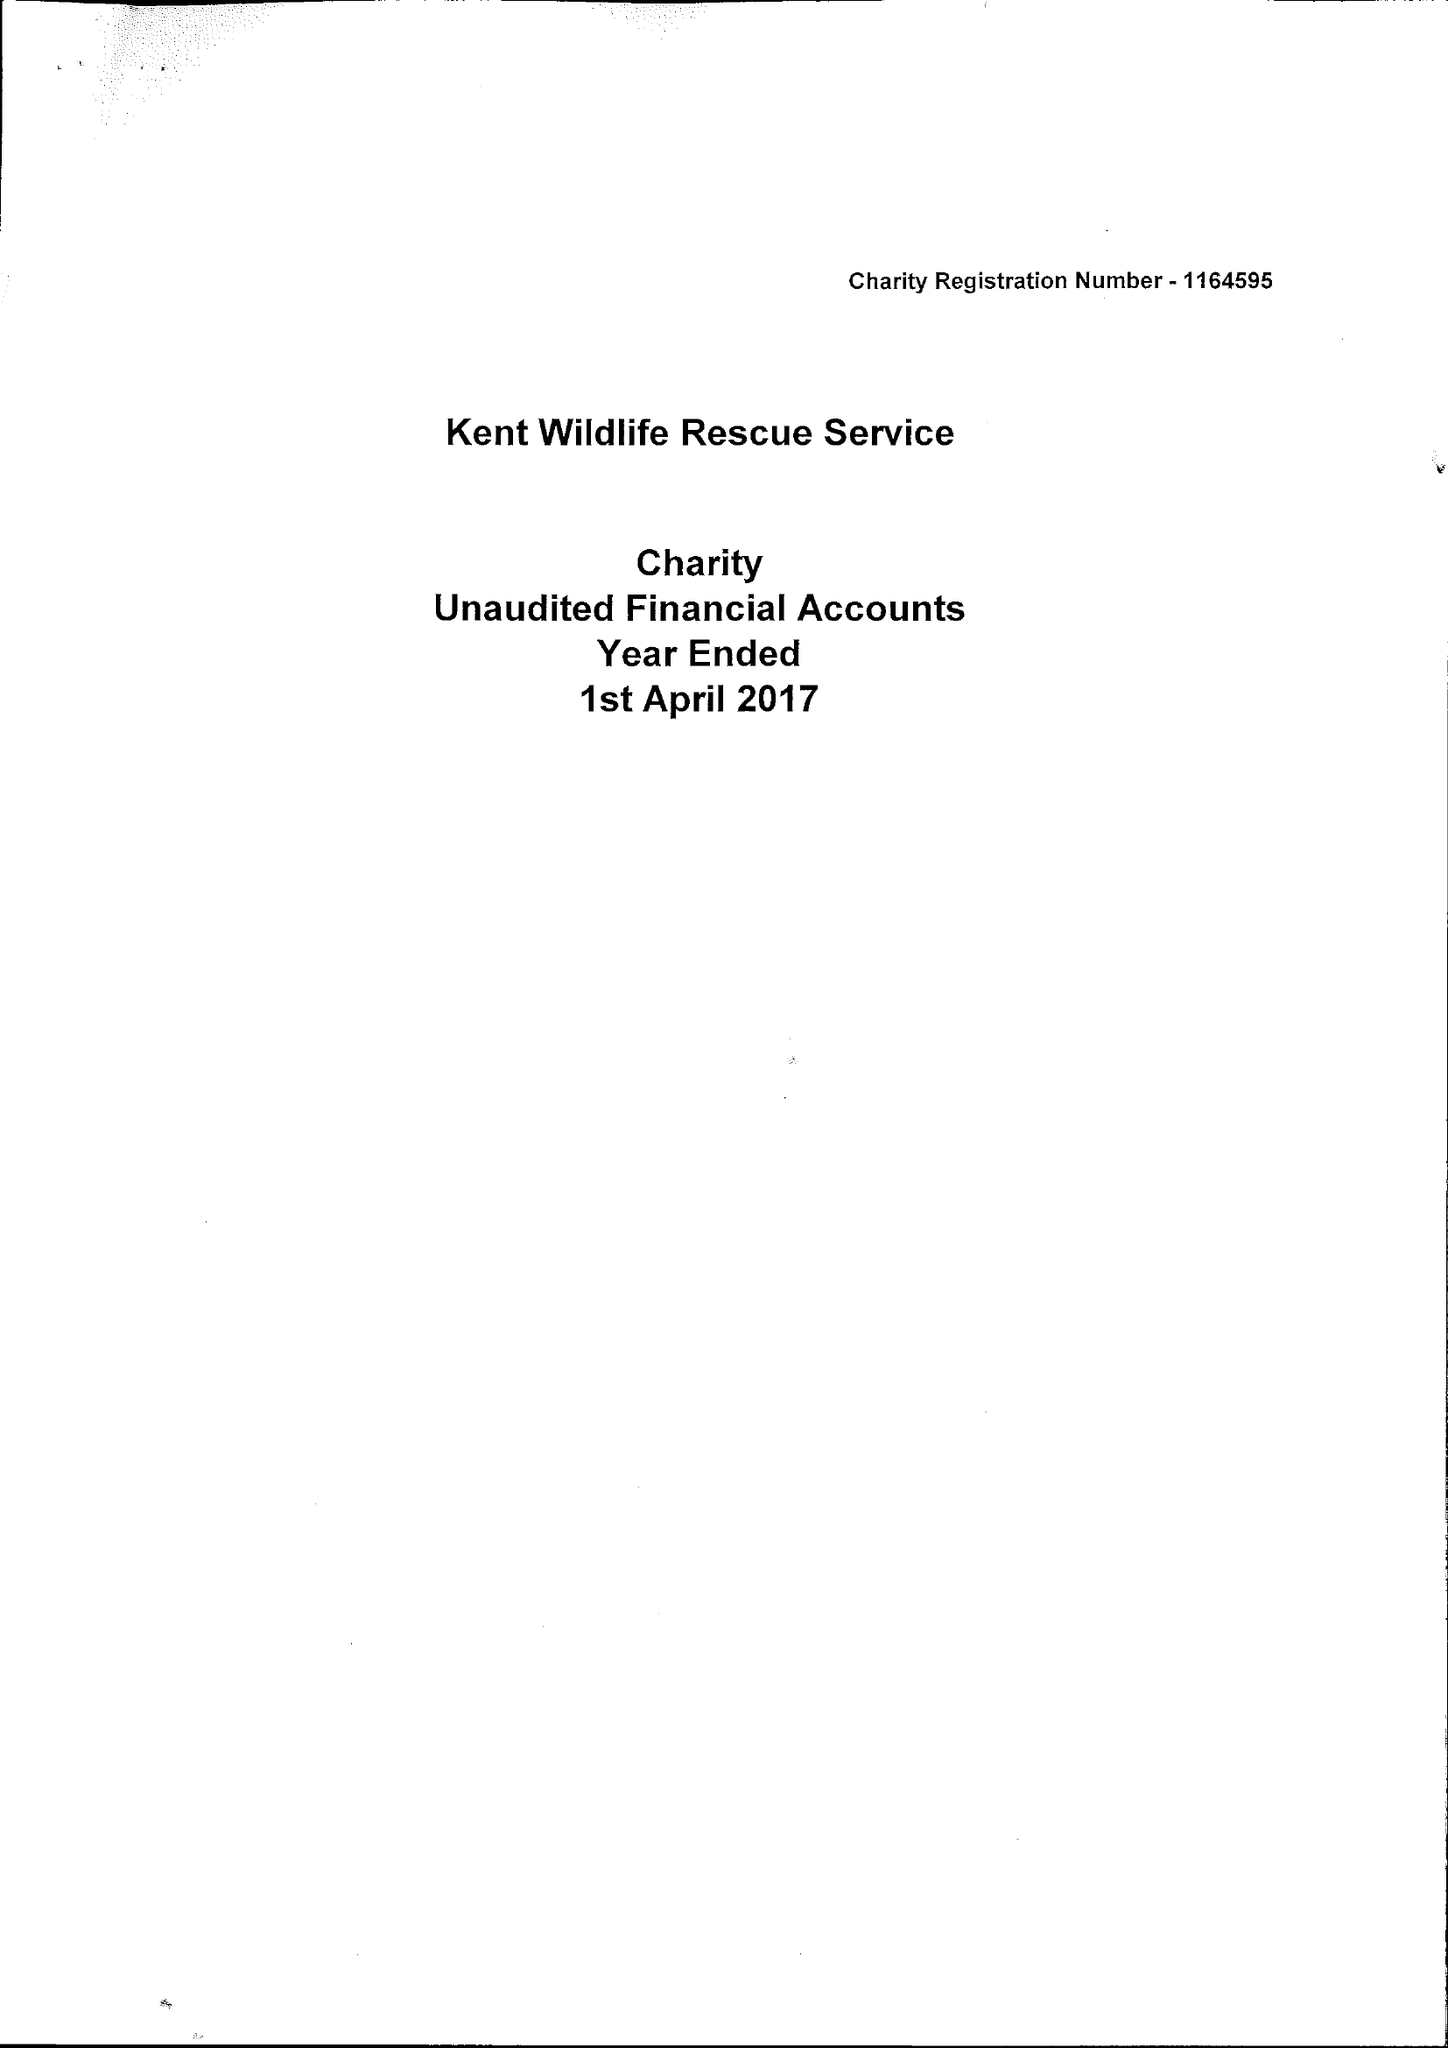What is the value for the charity_name?
Answer the question using a single word or phrase. Kent Wildlife Rescue Service 